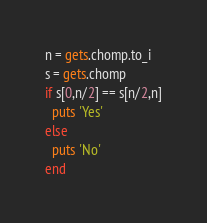<code> <loc_0><loc_0><loc_500><loc_500><_Ruby_>n = gets.chomp.to_i
s = gets.chomp
if s[0,n/2] == s[n/2,n]
  puts 'Yes'
else
  puts 'No'
end
</code> 